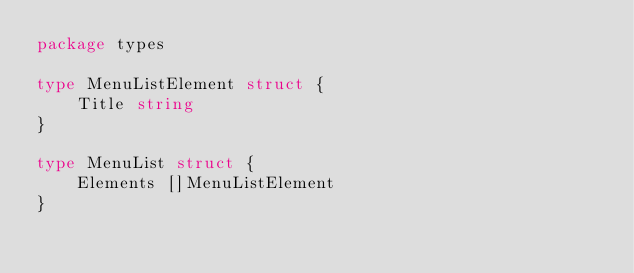<code> <loc_0><loc_0><loc_500><loc_500><_Go_>package types

type MenuListElement struct {
	Title string
}

type MenuList struct {
	Elements []MenuListElement
}
</code> 